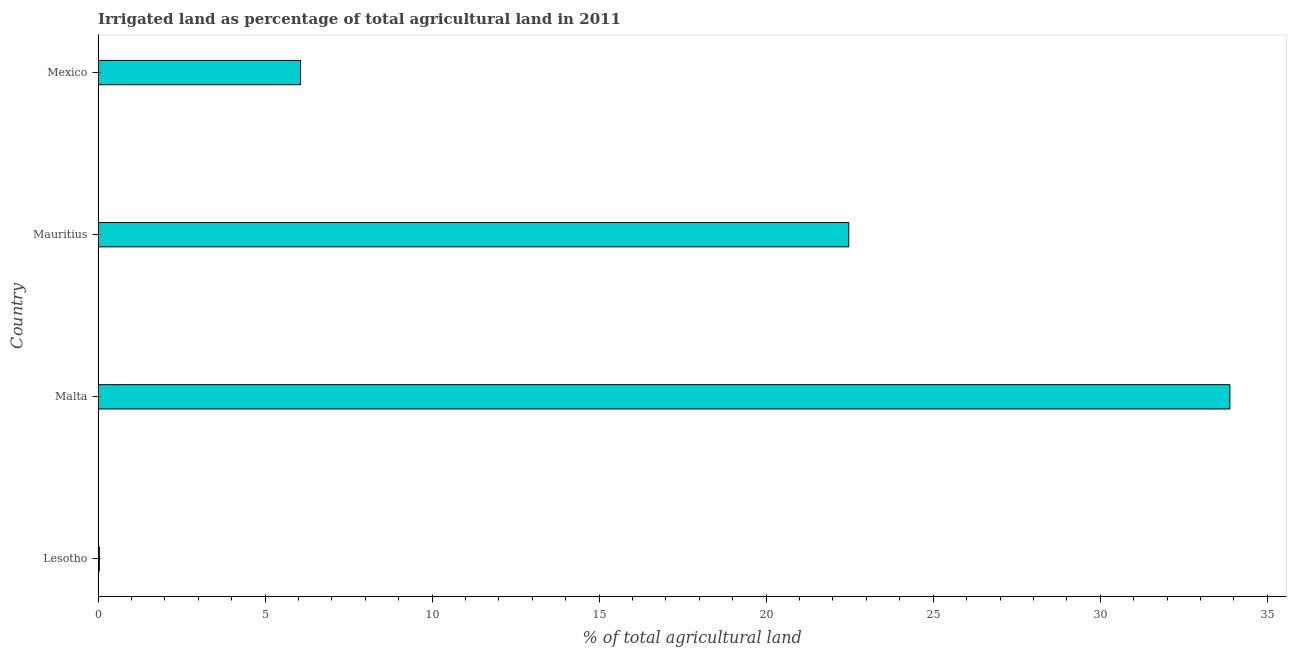Does the graph contain any zero values?
Ensure brevity in your answer.  No. Does the graph contain grids?
Your response must be concise. No. What is the title of the graph?
Your answer should be compact. Irrigated land as percentage of total agricultural land in 2011. What is the label or title of the X-axis?
Provide a short and direct response. % of total agricultural land. What is the percentage of agricultural irrigated land in Mexico?
Provide a succinct answer. 6.06. Across all countries, what is the maximum percentage of agricultural irrigated land?
Offer a terse response. 33.88. Across all countries, what is the minimum percentage of agricultural irrigated land?
Give a very brief answer. 0.04. In which country was the percentage of agricultural irrigated land maximum?
Your response must be concise. Malta. In which country was the percentage of agricultural irrigated land minimum?
Offer a very short reply. Lesotho. What is the sum of the percentage of agricultural irrigated land?
Your answer should be very brief. 62.46. What is the difference between the percentage of agricultural irrigated land in Lesotho and Malta?
Make the answer very short. -33.84. What is the average percentage of agricultural irrigated land per country?
Your answer should be compact. 15.61. What is the median percentage of agricultural irrigated land?
Provide a succinct answer. 14.27. In how many countries, is the percentage of agricultural irrigated land greater than 29 %?
Offer a very short reply. 1. What is the ratio of the percentage of agricultural irrigated land in Lesotho to that in Mauritius?
Your answer should be compact. 0. Is the difference between the percentage of agricultural irrigated land in Lesotho and Mauritius greater than the difference between any two countries?
Your response must be concise. No. What is the difference between the highest and the second highest percentage of agricultural irrigated land?
Provide a short and direct response. 11.41. What is the difference between the highest and the lowest percentage of agricultural irrigated land?
Your answer should be compact. 33.84. How many countries are there in the graph?
Offer a very short reply. 4. What is the % of total agricultural land of Lesotho?
Make the answer very short. 0.04. What is the % of total agricultural land in Malta?
Offer a very short reply. 33.88. What is the % of total agricultural land of Mauritius?
Ensure brevity in your answer.  22.47. What is the % of total agricultural land in Mexico?
Ensure brevity in your answer.  6.06. What is the difference between the % of total agricultural land in Lesotho and Malta?
Offer a very short reply. -33.84. What is the difference between the % of total agricultural land in Lesotho and Mauritius?
Provide a short and direct response. -22.43. What is the difference between the % of total agricultural land in Lesotho and Mexico?
Provide a short and direct response. -6.02. What is the difference between the % of total agricultural land in Malta and Mauritius?
Your answer should be very brief. 11.41. What is the difference between the % of total agricultural land in Malta and Mexico?
Provide a succinct answer. 27.82. What is the difference between the % of total agricultural land in Mauritius and Mexico?
Your response must be concise. 16.41. What is the ratio of the % of total agricultural land in Lesotho to that in Mauritius?
Provide a short and direct response. 0. What is the ratio of the % of total agricultural land in Lesotho to that in Mexico?
Your answer should be very brief. 0.01. What is the ratio of the % of total agricultural land in Malta to that in Mauritius?
Your answer should be very brief. 1.51. What is the ratio of the % of total agricultural land in Malta to that in Mexico?
Your answer should be very brief. 5.59. What is the ratio of the % of total agricultural land in Mauritius to that in Mexico?
Give a very brief answer. 3.71. 